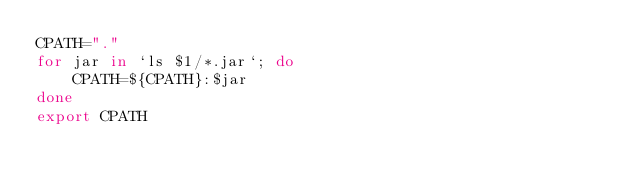<code> <loc_0><loc_0><loc_500><loc_500><_Bash_>CPATH="."
for jar in `ls $1/*.jar`; do
    CPATH=${CPATH}:$jar
done
export CPATH
</code> 